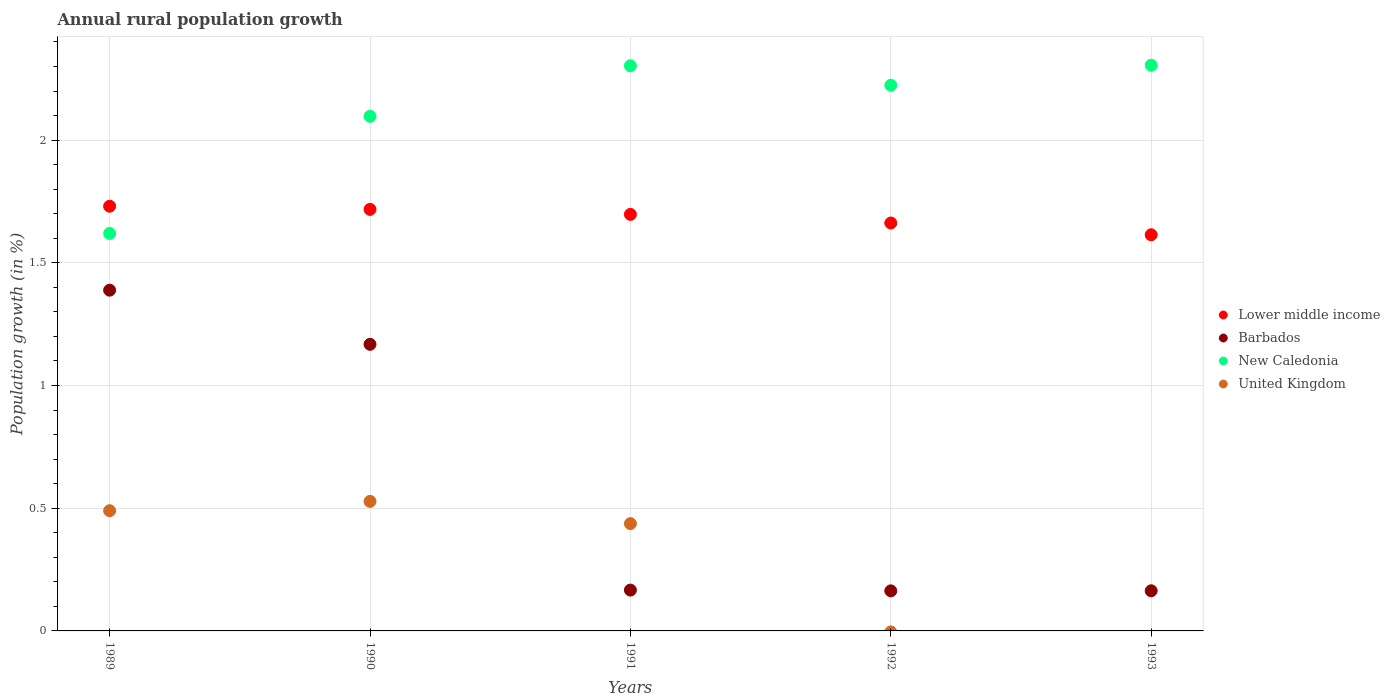Is the number of dotlines equal to the number of legend labels?
Your response must be concise. No. What is the percentage of rural population growth in Barbados in 1990?
Give a very brief answer. 1.17. Across all years, what is the maximum percentage of rural population growth in Lower middle income?
Provide a short and direct response. 1.73. Across all years, what is the minimum percentage of rural population growth in Barbados?
Offer a very short reply. 0.16. In which year was the percentage of rural population growth in Lower middle income maximum?
Ensure brevity in your answer.  1989. What is the total percentage of rural population growth in Barbados in the graph?
Provide a succinct answer. 3.05. What is the difference between the percentage of rural population growth in Barbados in 1990 and that in 1992?
Provide a succinct answer. 1. What is the difference between the percentage of rural population growth in Lower middle income in 1993 and the percentage of rural population growth in United Kingdom in 1989?
Offer a very short reply. 1.12. What is the average percentage of rural population growth in Lower middle income per year?
Your answer should be compact. 1.68. In the year 1992, what is the difference between the percentage of rural population growth in Barbados and percentage of rural population growth in New Caledonia?
Make the answer very short. -2.06. What is the ratio of the percentage of rural population growth in Barbados in 1990 to that in 1992?
Keep it short and to the point. 7.15. Is the percentage of rural population growth in New Caledonia in 1992 less than that in 1993?
Offer a terse response. Yes. What is the difference between the highest and the second highest percentage of rural population growth in United Kingdom?
Your answer should be very brief. 0.04. What is the difference between the highest and the lowest percentage of rural population growth in New Caledonia?
Your answer should be compact. 0.69. In how many years, is the percentage of rural population growth in United Kingdom greater than the average percentage of rural population growth in United Kingdom taken over all years?
Your response must be concise. 3. Is the sum of the percentage of rural population growth in Lower middle income in 1992 and 1993 greater than the maximum percentage of rural population growth in New Caledonia across all years?
Keep it short and to the point. Yes. Is it the case that in every year, the sum of the percentage of rural population growth in Barbados and percentage of rural population growth in Lower middle income  is greater than the percentage of rural population growth in United Kingdom?
Keep it short and to the point. Yes. Does the percentage of rural population growth in Lower middle income monotonically increase over the years?
Make the answer very short. No. Is the percentage of rural population growth in Barbados strictly greater than the percentage of rural population growth in New Caledonia over the years?
Give a very brief answer. No. Is the percentage of rural population growth in Barbados strictly less than the percentage of rural population growth in Lower middle income over the years?
Provide a short and direct response. Yes. How many dotlines are there?
Ensure brevity in your answer.  4. How many years are there in the graph?
Ensure brevity in your answer.  5. Are the values on the major ticks of Y-axis written in scientific E-notation?
Offer a terse response. No. Does the graph contain grids?
Keep it short and to the point. Yes. Where does the legend appear in the graph?
Keep it short and to the point. Center right. How are the legend labels stacked?
Provide a short and direct response. Vertical. What is the title of the graph?
Your response must be concise. Annual rural population growth. What is the label or title of the X-axis?
Make the answer very short. Years. What is the label or title of the Y-axis?
Offer a very short reply. Population growth (in %). What is the Population growth (in %) of Lower middle income in 1989?
Your answer should be very brief. 1.73. What is the Population growth (in %) of Barbados in 1989?
Give a very brief answer. 1.39. What is the Population growth (in %) in New Caledonia in 1989?
Your answer should be very brief. 1.62. What is the Population growth (in %) of United Kingdom in 1989?
Offer a terse response. 0.49. What is the Population growth (in %) of Lower middle income in 1990?
Ensure brevity in your answer.  1.72. What is the Population growth (in %) of Barbados in 1990?
Your answer should be very brief. 1.17. What is the Population growth (in %) of New Caledonia in 1990?
Offer a terse response. 2.1. What is the Population growth (in %) of United Kingdom in 1990?
Your answer should be compact. 0.53. What is the Population growth (in %) of Lower middle income in 1991?
Offer a terse response. 1.7. What is the Population growth (in %) in Barbados in 1991?
Offer a very short reply. 0.17. What is the Population growth (in %) of New Caledonia in 1991?
Offer a very short reply. 2.3. What is the Population growth (in %) in United Kingdom in 1991?
Offer a terse response. 0.44. What is the Population growth (in %) of Lower middle income in 1992?
Ensure brevity in your answer.  1.66. What is the Population growth (in %) in Barbados in 1992?
Keep it short and to the point. 0.16. What is the Population growth (in %) in New Caledonia in 1992?
Provide a succinct answer. 2.22. What is the Population growth (in %) in Lower middle income in 1993?
Ensure brevity in your answer.  1.61. What is the Population growth (in %) in Barbados in 1993?
Provide a succinct answer. 0.16. What is the Population growth (in %) in New Caledonia in 1993?
Offer a very short reply. 2.3. What is the Population growth (in %) of United Kingdom in 1993?
Give a very brief answer. 0. Across all years, what is the maximum Population growth (in %) of Lower middle income?
Your answer should be compact. 1.73. Across all years, what is the maximum Population growth (in %) in Barbados?
Your answer should be compact. 1.39. Across all years, what is the maximum Population growth (in %) of New Caledonia?
Provide a succinct answer. 2.3. Across all years, what is the maximum Population growth (in %) of United Kingdom?
Provide a short and direct response. 0.53. Across all years, what is the minimum Population growth (in %) of Lower middle income?
Offer a terse response. 1.61. Across all years, what is the minimum Population growth (in %) in Barbados?
Your answer should be very brief. 0.16. Across all years, what is the minimum Population growth (in %) in New Caledonia?
Offer a very short reply. 1.62. What is the total Population growth (in %) of Lower middle income in the graph?
Offer a very short reply. 8.42. What is the total Population growth (in %) of Barbados in the graph?
Offer a terse response. 3.05. What is the total Population growth (in %) of New Caledonia in the graph?
Make the answer very short. 10.55. What is the total Population growth (in %) of United Kingdom in the graph?
Provide a short and direct response. 1.46. What is the difference between the Population growth (in %) in Lower middle income in 1989 and that in 1990?
Keep it short and to the point. 0.01. What is the difference between the Population growth (in %) of Barbados in 1989 and that in 1990?
Keep it short and to the point. 0.22. What is the difference between the Population growth (in %) in New Caledonia in 1989 and that in 1990?
Provide a succinct answer. -0.48. What is the difference between the Population growth (in %) in United Kingdom in 1989 and that in 1990?
Make the answer very short. -0.04. What is the difference between the Population growth (in %) in Lower middle income in 1989 and that in 1991?
Provide a short and direct response. 0.03. What is the difference between the Population growth (in %) of Barbados in 1989 and that in 1991?
Ensure brevity in your answer.  1.22. What is the difference between the Population growth (in %) in New Caledonia in 1989 and that in 1991?
Ensure brevity in your answer.  -0.68. What is the difference between the Population growth (in %) in United Kingdom in 1989 and that in 1991?
Provide a short and direct response. 0.05. What is the difference between the Population growth (in %) of Lower middle income in 1989 and that in 1992?
Offer a very short reply. 0.07. What is the difference between the Population growth (in %) in Barbados in 1989 and that in 1992?
Provide a short and direct response. 1.23. What is the difference between the Population growth (in %) in New Caledonia in 1989 and that in 1992?
Ensure brevity in your answer.  -0.6. What is the difference between the Population growth (in %) of Lower middle income in 1989 and that in 1993?
Offer a very short reply. 0.12. What is the difference between the Population growth (in %) in Barbados in 1989 and that in 1993?
Give a very brief answer. 1.22. What is the difference between the Population growth (in %) in New Caledonia in 1989 and that in 1993?
Your answer should be compact. -0.69. What is the difference between the Population growth (in %) of Lower middle income in 1990 and that in 1991?
Ensure brevity in your answer.  0.02. What is the difference between the Population growth (in %) in Barbados in 1990 and that in 1991?
Your response must be concise. 1. What is the difference between the Population growth (in %) of New Caledonia in 1990 and that in 1991?
Ensure brevity in your answer.  -0.21. What is the difference between the Population growth (in %) of United Kingdom in 1990 and that in 1991?
Give a very brief answer. 0.09. What is the difference between the Population growth (in %) of Lower middle income in 1990 and that in 1992?
Keep it short and to the point. 0.06. What is the difference between the Population growth (in %) in Barbados in 1990 and that in 1992?
Make the answer very short. 1. What is the difference between the Population growth (in %) of New Caledonia in 1990 and that in 1992?
Give a very brief answer. -0.13. What is the difference between the Population growth (in %) of Lower middle income in 1990 and that in 1993?
Make the answer very short. 0.1. What is the difference between the Population growth (in %) of New Caledonia in 1990 and that in 1993?
Give a very brief answer. -0.21. What is the difference between the Population growth (in %) of Lower middle income in 1991 and that in 1992?
Give a very brief answer. 0.04. What is the difference between the Population growth (in %) of Barbados in 1991 and that in 1992?
Keep it short and to the point. 0. What is the difference between the Population growth (in %) of New Caledonia in 1991 and that in 1992?
Ensure brevity in your answer.  0.08. What is the difference between the Population growth (in %) in Lower middle income in 1991 and that in 1993?
Give a very brief answer. 0.08. What is the difference between the Population growth (in %) in Barbados in 1991 and that in 1993?
Provide a short and direct response. 0. What is the difference between the Population growth (in %) of New Caledonia in 1991 and that in 1993?
Give a very brief answer. -0. What is the difference between the Population growth (in %) in Lower middle income in 1992 and that in 1993?
Your answer should be compact. 0.05. What is the difference between the Population growth (in %) in Barbados in 1992 and that in 1993?
Your answer should be very brief. -0. What is the difference between the Population growth (in %) of New Caledonia in 1992 and that in 1993?
Offer a terse response. -0.08. What is the difference between the Population growth (in %) of Lower middle income in 1989 and the Population growth (in %) of Barbados in 1990?
Provide a succinct answer. 0.56. What is the difference between the Population growth (in %) of Lower middle income in 1989 and the Population growth (in %) of New Caledonia in 1990?
Your answer should be very brief. -0.37. What is the difference between the Population growth (in %) of Lower middle income in 1989 and the Population growth (in %) of United Kingdom in 1990?
Your response must be concise. 1.2. What is the difference between the Population growth (in %) of Barbados in 1989 and the Population growth (in %) of New Caledonia in 1990?
Offer a terse response. -0.71. What is the difference between the Population growth (in %) in Barbados in 1989 and the Population growth (in %) in United Kingdom in 1990?
Ensure brevity in your answer.  0.86. What is the difference between the Population growth (in %) of New Caledonia in 1989 and the Population growth (in %) of United Kingdom in 1990?
Make the answer very short. 1.09. What is the difference between the Population growth (in %) of Lower middle income in 1989 and the Population growth (in %) of Barbados in 1991?
Keep it short and to the point. 1.56. What is the difference between the Population growth (in %) of Lower middle income in 1989 and the Population growth (in %) of New Caledonia in 1991?
Provide a short and direct response. -0.57. What is the difference between the Population growth (in %) in Lower middle income in 1989 and the Population growth (in %) in United Kingdom in 1991?
Your response must be concise. 1.29. What is the difference between the Population growth (in %) in Barbados in 1989 and the Population growth (in %) in New Caledonia in 1991?
Provide a short and direct response. -0.91. What is the difference between the Population growth (in %) in Barbados in 1989 and the Population growth (in %) in United Kingdom in 1991?
Make the answer very short. 0.95. What is the difference between the Population growth (in %) in New Caledonia in 1989 and the Population growth (in %) in United Kingdom in 1991?
Provide a succinct answer. 1.18. What is the difference between the Population growth (in %) of Lower middle income in 1989 and the Population growth (in %) of Barbados in 1992?
Your answer should be compact. 1.57. What is the difference between the Population growth (in %) of Lower middle income in 1989 and the Population growth (in %) of New Caledonia in 1992?
Ensure brevity in your answer.  -0.49. What is the difference between the Population growth (in %) of Barbados in 1989 and the Population growth (in %) of New Caledonia in 1992?
Offer a very short reply. -0.83. What is the difference between the Population growth (in %) of Lower middle income in 1989 and the Population growth (in %) of Barbados in 1993?
Your answer should be very brief. 1.57. What is the difference between the Population growth (in %) of Lower middle income in 1989 and the Population growth (in %) of New Caledonia in 1993?
Provide a succinct answer. -0.57. What is the difference between the Population growth (in %) in Barbados in 1989 and the Population growth (in %) in New Caledonia in 1993?
Your answer should be very brief. -0.92. What is the difference between the Population growth (in %) in Lower middle income in 1990 and the Population growth (in %) in Barbados in 1991?
Keep it short and to the point. 1.55. What is the difference between the Population growth (in %) of Lower middle income in 1990 and the Population growth (in %) of New Caledonia in 1991?
Provide a short and direct response. -0.59. What is the difference between the Population growth (in %) of Lower middle income in 1990 and the Population growth (in %) of United Kingdom in 1991?
Make the answer very short. 1.28. What is the difference between the Population growth (in %) of Barbados in 1990 and the Population growth (in %) of New Caledonia in 1991?
Your answer should be compact. -1.14. What is the difference between the Population growth (in %) of Barbados in 1990 and the Population growth (in %) of United Kingdom in 1991?
Give a very brief answer. 0.73. What is the difference between the Population growth (in %) in New Caledonia in 1990 and the Population growth (in %) in United Kingdom in 1991?
Your answer should be very brief. 1.66. What is the difference between the Population growth (in %) of Lower middle income in 1990 and the Population growth (in %) of Barbados in 1992?
Offer a very short reply. 1.55. What is the difference between the Population growth (in %) of Lower middle income in 1990 and the Population growth (in %) of New Caledonia in 1992?
Provide a succinct answer. -0.51. What is the difference between the Population growth (in %) of Barbados in 1990 and the Population growth (in %) of New Caledonia in 1992?
Make the answer very short. -1.06. What is the difference between the Population growth (in %) of Lower middle income in 1990 and the Population growth (in %) of Barbados in 1993?
Your answer should be compact. 1.55. What is the difference between the Population growth (in %) in Lower middle income in 1990 and the Population growth (in %) in New Caledonia in 1993?
Give a very brief answer. -0.59. What is the difference between the Population growth (in %) in Barbados in 1990 and the Population growth (in %) in New Caledonia in 1993?
Your answer should be compact. -1.14. What is the difference between the Population growth (in %) in Lower middle income in 1991 and the Population growth (in %) in Barbados in 1992?
Your answer should be very brief. 1.53. What is the difference between the Population growth (in %) in Lower middle income in 1991 and the Population growth (in %) in New Caledonia in 1992?
Ensure brevity in your answer.  -0.53. What is the difference between the Population growth (in %) of Barbados in 1991 and the Population growth (in %) of New Caledonia in 1992?
Provide a short and direct response. -2.06. What is the difference between the Population growth (in %) of Lower middle income in 1991 and the Population growth (in %) of Barbados in 1993?
Your response must be concise. 1.53. What is the difference between the Population growth (in %) of Lower middle income in 1991 and the Population growth (in %) of New Caledonia in 1993?
Your answer should be very brief. -0.61. What is the difference between the Population growth (in %) of Barbados in 1991 and the Population growth (in %) of New Caledonia in 1993?
Ensure brevity in your answer.  -2.14. What is the difference between the Population growth (in %) in Lower middle income in 1992 and the Population growth (in %) in Barbados in 1993?
Your response must be concise. 1.5. What is the difference between the Population growth (in %) of Lower middle income in 1992 and the Population growth (in %) of New Caledonia in 1993?
Provide a short and direct response. -0.64. What is the difference between the Population growth (in %) in Barbados in 1992 and the Population growth (in %) in New Caledonia in 1993?
Your answer should be very brief. -2.14. What is the average Population growth (in %) in Lower middle income per year?
Offer a very short reply. 1.68. What is the average Population growth (in %) of Barbados per year?
Your response must be concise. 0.61. What is the average Population growth (in %) in New Caledonia per year?
Ensure brevity in your answer.  2.11. What is the average Population growth (in %) in United Kingdom per year?
Ensure brevity in your answer.  0.29. In the year 1989, what is the difference between the Population growth (in %) of Lower middle income and Population growth (in %) of Barbados?
Your answer should be very brief. 0.34. In the year 1989, what is the difference between the Population growth (in %) in Lower middle income and Population growth (in %) in New Caledonia?
Provide a short and direct response. 0.11. In the year 1989, what is the difference between the Population growth (in %) of Lower middle income and Population growth (in %) of United Kingdom?
Offer a very short reply. 1.24. In the year 1989, what is the difference between the Population growth (in %) in Barbados and Population growth (in %) in New Caledonia?
Provide a succinct answer. -0.23. In the year 1989, what is the difference between the Population growth (in %) in Barbados and Population growth (in %) in United Kingdom?
Offer a very short reply. 0.9. In the year 1989, what is the difference between the Population growth (in %) in New Caledonia and Population growth (in %) in United Kingdom?
Your response must be concise. 1.13. In the year 1990, what is the difference between the Population growth (in %) of Lower middle income and Population growth (in %) of Barbados?
Offer a terse response. 0.55. In the year 1990, what is the difference between the Population growth (in %) of Lower middle income and Population growth (in %) of New Caledonia?
Keep it short and to the point. -0.38. In the year 1990, what is the difference between the Population growth (in %) in Lower middle income and Population growth (in %) in United Kingdom?
Your answer should be very brief. 1.19. In the year 1990, what is the difference between the Population growth (in %) of Barbados and Population growth (in %) of New Caledonia?
Your answer should be compact. -0.93. In the year 1990, what is the difference between the Population growth (in %) in Barbados and Population growth (in %) in United Kingdom?
Keep it short and to the point. 0.64. In the year 1990, what is the difference between the Population growth (in %) of New Caledonia and Population growth (in %) of United Kingdom?
Keep it short and to the point. 1.57. In the year 1991, what is the difference between the Population growth (in %) of Lower middle income and Population growth (in %) of Barbados?
Provide a short and direct response. 1.53. In the year 1991, what is the difference between the Population growth (in %) in Lower middle income and Population growth (in %) in New Caledonia?
Your response must be concise. -0.61. In the year 1991, what is the difference between the Population growth (in %) of Lower middle income and Population growth (in %) of United Kingdom?
Make the answer very short. 1.26. In the year 1991, what is the difference between the Population growth (in %) of Barbados and Population growth (in %) of New Caledonia?
Give a very brief answer. -2.14. In the year 1991, what is the difference between the Population growth (in %) of Barbados and Population growth (in %) of United Kingdom?
Provide a short and direct response. -0.27. In the year 1991, what is the difference between the Population growth (in %) of New Caledonia and Population growth (in %) of United Kingdom?
Make the answer very short. 1.87. In the year 1992, what is the difference between the Population growth (in %) in Lower middle income and Population growth (in %) in Barbados?
Ensure brevity in your answer.  1.5. In the year 1992, what is the difference between the Population growth (in %) of Lower middle income and Population growth (in %) of New Caledonia?
Give a very brief answer. -0.56. In the year 1992, what is the difference between the Population growth (in %) in Barbados and Population growth (in %) in New Caledonia?
Your response must be concise. -2.06. In the year 1993, what is the difference between the Population growth (in %) in Lower middle income and Population growth (in %) in Barbados?
Give a very brief answer. 1.45. In the year 1993, what is the difference between the Population growth (in %) in Lower middle income and Population growth (in %) in New Caledonia?
Keep it short and to the point. -0.69. In the year 1993, what is the difference between the Population growth (in %) of Barbados and Population growth (in %) of New Caledonia?
Your response must be concise. -2.14. What is the ratio of the Population growth (in %) in Lower middle income in 1989 to that in 1990?
Give a very brief answer. 1.01. What is the ratio of the Population growth (in %) in Barbados in 1989 to that in 1990?
Your response must be concise. 1.19. What is the ratio of the Population growth (in %) in New Caledonia in 1989 to that in 1990?
Make the answer very short. 0.77. What is the ratio of the Population growth (in %) of United Kingdom in 1989 to that in 1990?
Your answer should be very brief. 0.93. What is the ratio of the Population growth (in %) of Lower middle income in 1989 to that in 1991?
Keep it short and to the point. 1.02. What is the ratio of the Population growth (in %) of Barbados in 1989 to that in 1991?
Ensure brevity in your answer.  8.35. What is the ratio of the Population growth (in %) in New Caledonia in 1989 to that in 1991?
Offer a terse response. 0.7. What is the ratio of the Population growth (in %) in United Kingdom in 1989 to that in 1991?
Ensure brevity in your answer.  1.12. What is the ratio of the Population growth (in %) of Lower middle income in 1989 to that in 1992?
Give a very brief answer. 1.04. What is the ratio of the Population growth (in %) of Barbados in 1989 to that in 1992?
Offer a very short reply. 8.51. What is the ratio of the Population growth (in %) of New Caledonia in 1989 to that in 1992?
Provide a succinct answer. 0.73. What is the ratio of the Population growth (in %) of Lower middle income in 1989 to that in 1993?
Keep it short and to the point. 1.07. What is the ratio of the Population growth (in %) of Barbados in 1989 to that in 1993?
Your response must be concise. 8.49. What is the ratio of the Population growth (in %) of New Caledonia in 1989 to that in 1993?
Offer a terse response. 0.7. What is the ratio of the Population growth (in %) in Lower middle income in 1990 to that in 1991?
Your answer should be very brief. 1.01. What is the ratio of the Population growth (in %) in Barbados in 1990 to that in 1991?
Provide a short and direct response. 7.02. What is the ratio of the Population growth (in %) of New Caledonia in 1990 to that in 1991?
Your response must be concise. 0.91. What is the ratio of the Population growth (in %) of United Kingdom in 1990 to that in 1991?
Make the answer very short. 1.21. What is the ratio of the Population growth (in %) of Lower middle income in 1990 to that in 1992?
Provide a short and direct response. 1.03. What is the ratio of the Population growth (in %) of Barbados in 1990 to that in 1992?
Ensure brevity in your answer.  7.15. What is the ratio of the Population growth (in %) of New Caledonia in 1990 to that in 1992?
Your response must be concise. 0.94. What is the ratio of the Population growth (in %) of Lower middle income in 1990 to that in 1993?
Your response must be concise. 1.06. What is the ratio of the Population growth (in %) of Barbados in 1990 to that in 1993?
Offer a very short reply. 7.14. What is the ratio of the Population growth (in %) in New Caledonia in 1990 to that in 1993?
Ensure brevity in your answer.  0.91. What is the ratio of the Population growth (in %) of Lower middle income in 1991 to that in 1992?
Your answer should be very brief. 1.02. What is the ratio of the Population growth (in %) in Barbados in 1991 to that in 1992?
Make the answer very short. 1.02. What is the ratio of the Population growth (in %) in New Caledonia in 1991 to that in 1992?
Your answer should be compact. 1.04. What is the ratio of the Population growth (in %) in Lower middle income in 1991 to that in 1993?
Offer a very short reply. 1.05. What is the ratio of the Population growth (in %) in Barbados in 1991 to that in 1993?
Ensure brevity in your answer.  1.02. What is the ratio of the Population growth (in %) in Lower middle income in 1992 to that in 1993?
Offer a very short reply. 1.03. What is the ratio of the Population growth (in %) in Barbados in 1992 to that in 1993?
Give a very brief answer. 1. What is the ratio of the Population growth (in %) of New Caledonia in 1992 to that in 1993?
Give a very brief answer. 0.96. What is the difference between the highest and the second highest Population growth (in %) in Lower middle income?
Provide a short and direct response. 0.01. What is the difference between the highest and the second highest Population growth (in %) in Barbados?
Ensure brevity in your answer.  0.22. What is the difference between the highest and the second highest Population growth (in %) of New Caledonia?
Make the answer very short. 0. What is the difference between the highest and the second highest Population growth (in %) in United Kingdom?
Offer a terse response. 0.04. What is the difference between the highest and the lowest Population growth (in %) of Lower middle income?
Your response must be concise. 0.12. What is the difference between the highest and the lowest Population growth (in %) of Barbados?
Your answer should be compact. 1.23. What is the difference between the highest and the lowest Population growth (in %) in New Caledonia?
Your answer should be very brief. 0.69. What is the difference between the highest and the lowest Population growth (in %) in United Kingdom?
Your answer should be compact. 0.53. 